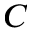Convert formula to latex. <formula><loc_0><loc_0><loc_500><loc_500>C</formula> 